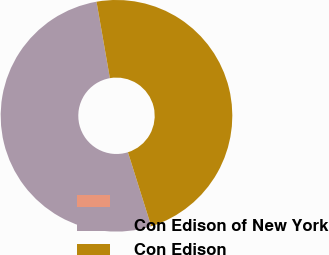<chart> <loc_0><loc_0><loc_500><loc_500><pie_chart><ecel><fcel>Con Edison of New York<fcel>Con Edison<nl><fcel>0.0%<fcel>52.09%<fcel>47.91%<nl></chart> 